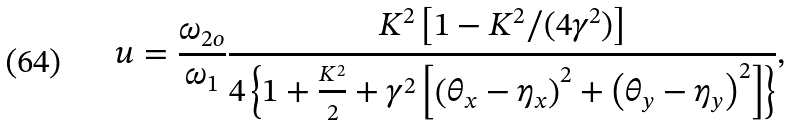<formula> <loc_0><loc_0><loc_500><loc_500>u = \frac { \omega _ { 2 o } } { \omega _ { 1 } } \frac { K ^ { 2 } \left [ 1 - K ^ { 2 } / ( 4 \gamma ^ { 2 } ) \right ] } { 4 \left \{ 1 + \frac { K ^ { 2 } } { 2 } + \gamma ^ { 2 } \left [ \left ( \theta _ { x } - \eta _ { x } \right ) ^ { 2 } + \left ( \theta _ { y } - \eta _ { y } \right ) ^ { 2 } \right ] \right \} } ,</formula> 